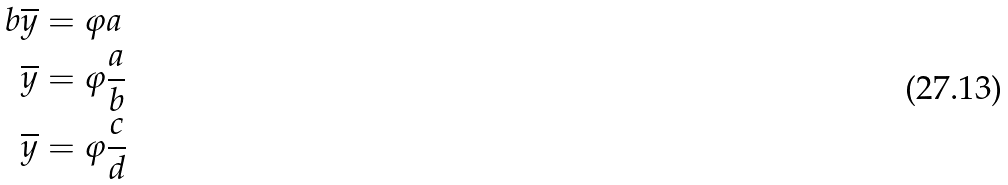Convert formula to latex. <formula><loc_0><loc_0><loc_500><loc_500>b \overline { y } & = \varphi a \\ \overline { y } & = \varphi \frac { a } { b } \\ \overline { y } & = \varphi \frac { c } { d }</formula> 